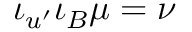Convert formula to latex. <formula><loc_0><loc_0><loc_500><loc_500>\iota _ { u ^ { \prime } } \iota _ { B } \mu = \nu</formula> 